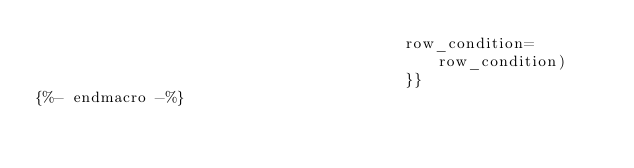Convert code to text. <code><loc_0><loc_0><loc_500><loc_500><_SQL_>                                        row_condition=row_condition)
                                        }}
{%- endmacro -%}
</code> 